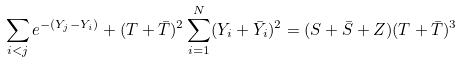Convert formula to latex. <formula><loc_0><loc_0><loc_500><loc_500>\sum _ { i < j } e ^ { - ( Y _ { j } - Y _ { i } ) } + ( T + \bar { T } ) ^ { 2 } \sum _ { i = 1 } ^ { N } ( Y _ { i } + \bar { Y _ { i } } ) ^ { 2 } = ( S + \bar { S } + Z ) ( T + \bar { T } ) ^ { 3 }</formula> 